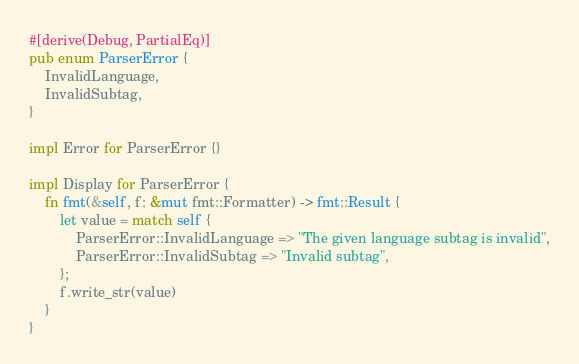<code> <loc_0><loc_0><loc_500><loc_500><_Rust_>#[derive(Debug, PartialEq)]
pub enum ParserError {
    InvalidLanguage,
    InvalidSubtag,
}

impl Error for ParserError {}

impl Display for ParserError {
    fn fmt(&self, f: &mut fmt::Formatter) -> fmt::Result {
        let value = match self {
            ParserError::InvalidLanguage => "The given language subtag is invalid",
            ParserError::InvalidSubtag => "Invalid subtag",
        };
        f.write_str(value)
    }
}
</code> 